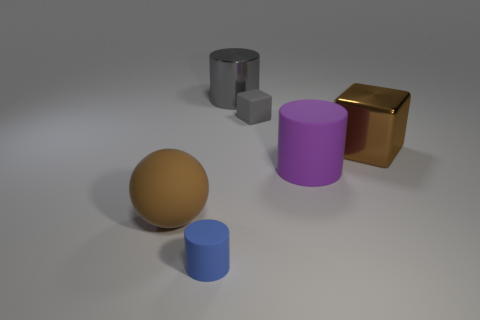Is the color of the big metal cylinder the same as the tiny matte cube?
Keep it short and to the point. Yes. What number of other objects are the same shape as the large gray metal thing?
Your answer should be compact. 2. There is a metallic thing to the right of the purple cylinder; does it have the same shape as the small matte object that is on the right side of the blue rubber thing?
Provide a short and direct response. Yes. There is a rubber cylinder behind the big matte thing on the left side of the tiny blue cylinder; what number of brown cubes are in front of it?
Give a very brief answer. 0. The small matte cylinder is what color?
Offer a terse response. Blue. What number of other objects are the same size as the gray matte cube?
Keep it short and to the point. 1. There is a large gray object that is the same shape as the small blue matte thing; what is it made of?
Your answer should be compact. Metal. What is the object that is on the right side of the large matte object on the right side of the small matte object that is left of the gray rubber block made of?
Your answer should be very brief. Metal. There is a purple cylinder that is the same material as the large ball; what is its size?
Provide a short and direct response. Large. Are there any other things that are the same color as the metallic cube?
Your answer should be very brief. Yes. 